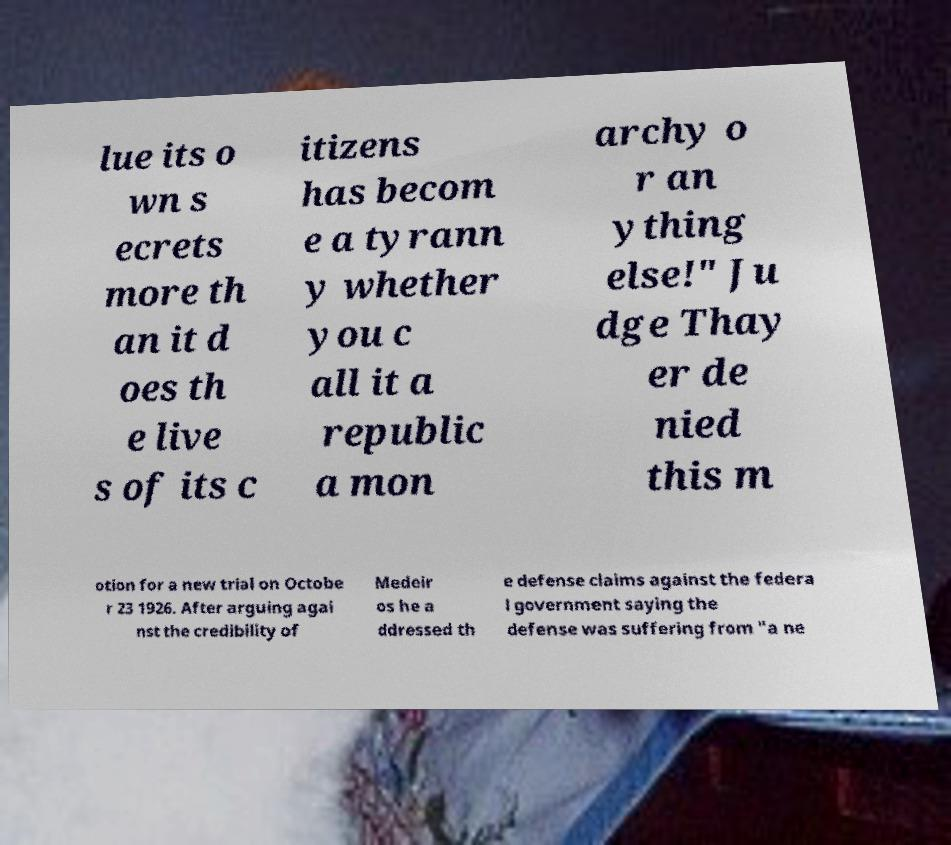For documentation purposes, I need the text within this image transcribed. Could you provide that? lue its o wn s ecrets more th an it d oes th e live s of its c itizens has becom e a tyrann y whether you c all it a republic a mon archy o r an ything else!" Ju dge Thay er de nied this m otion for a new trial on Octobe r 23 1926. After arguing agai nst the credibility of Medeir os he a ddressed th e defense claims against the federa l government saying the defense was suffering from "a ne 